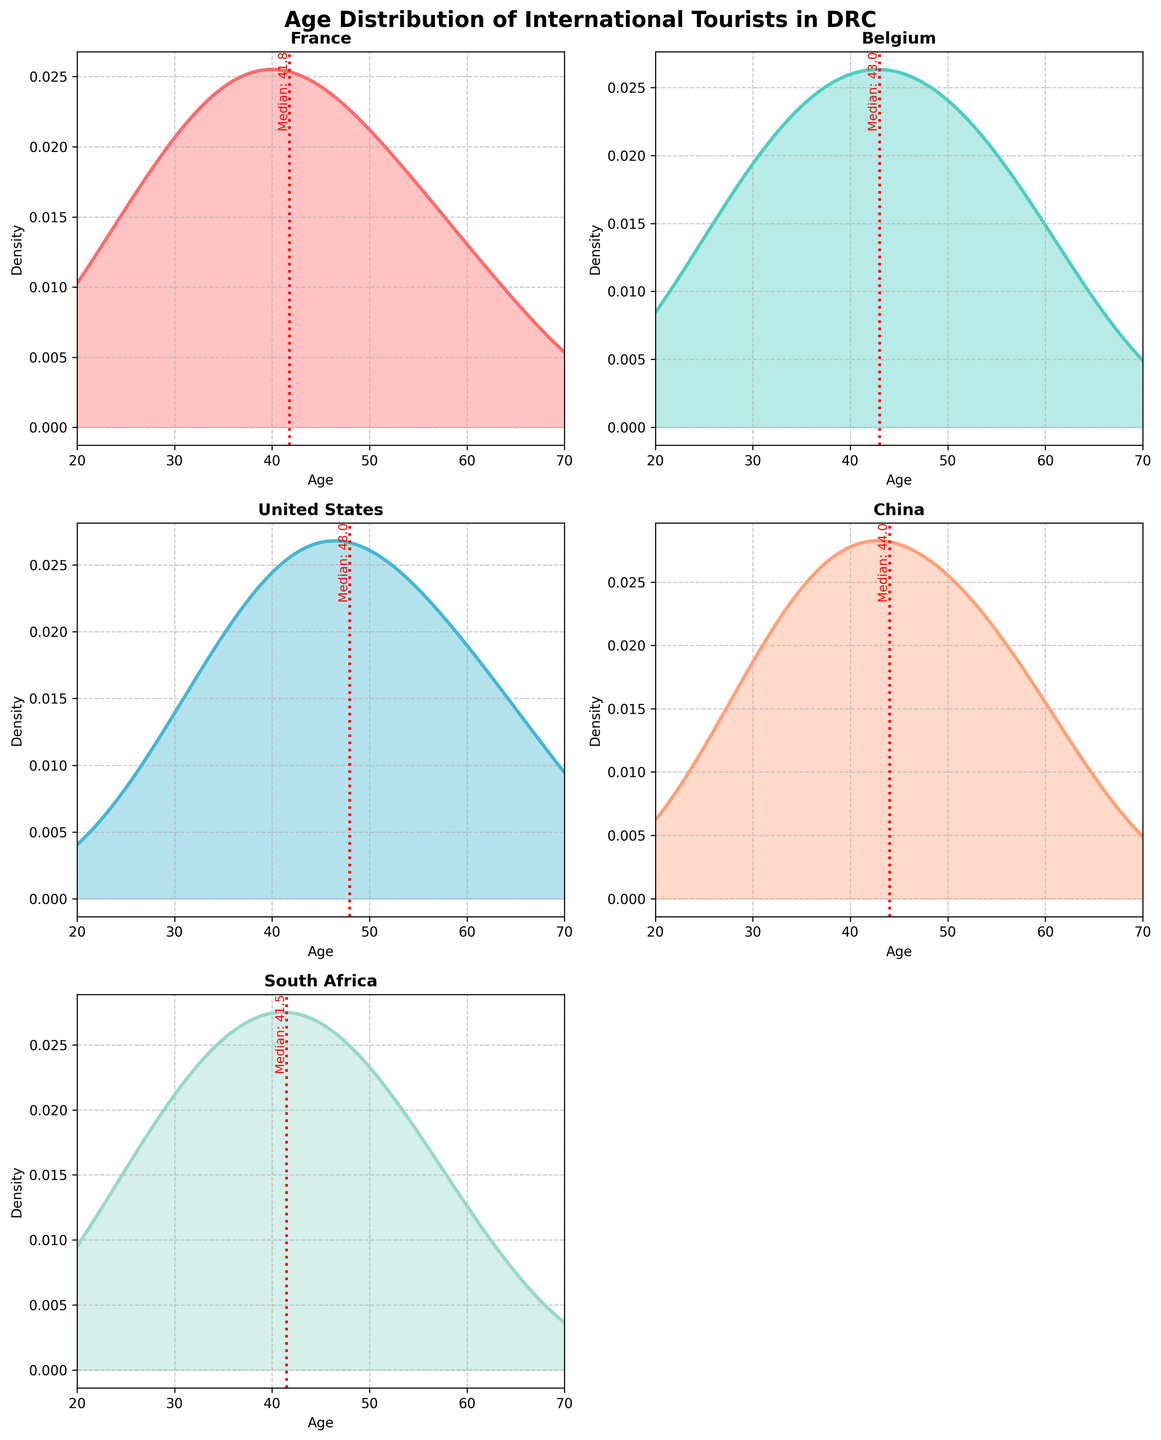What's the title of the figure? The title of the figure is at the top of the plot. It reads 'Age Distribution of International Tourists in DRC' and it is in bold font.
Answer: Age Distribution of International Tourists in DRC How many countries' age distributions are shown in the figure? By examining the titles in each subplot, which correspond to different countries, you can see that there are six countries' age distributions shown.
Answer: Six Which age group has the highest density for tourists from France? The density plot showcases peaks where the density values are the highest. For France, the peak occurs near the age of 42.
Answer: 42 What is the color used for the density plot of Belgium? Each country is represented using a distinct color in the plots. By inspecting the Belgium plot, you can observe it is represented in a shade of green.
Answer: Green What is the median age of tourists from the United States? In the subplot for the United States, a vertical red dashed line indicates the median value of tourist ages. The label next to the line shows the value.
Answer: 47.9 Which country has the lowest median age for tourists? Compare the positions of the vertical red dashed lines in each subplot. The country with the line furthest left has the youngest median age, which is France.
Answer: France How does the age distribution of tourists from China compare with that of the United States? Comparing the density plots for China and the United States, note the overall shape and where the peaks occur. The United States has an older median age and a slightly broader age distribution than China.
Answer: Older and broader for the United States Which country shows the widest spread in the age distribution? The width of the density plot indicates the spread of the distribution. South Africa's plot appears to be the broadest, indicating the widest age range among its tourists.
Answer: South Africa Which age group has the lowest density for tourists from Belgium? Belgium's plot shows density valleys (lowest points). The age group around 25 shows the lowest density.
Answer: Around 25 Is there any empty subplot in the figure? By inspecting all subplots, you find one subplot without any data, which is the bottom right section. This subplot's axes are turned off.
Answer: Yes 